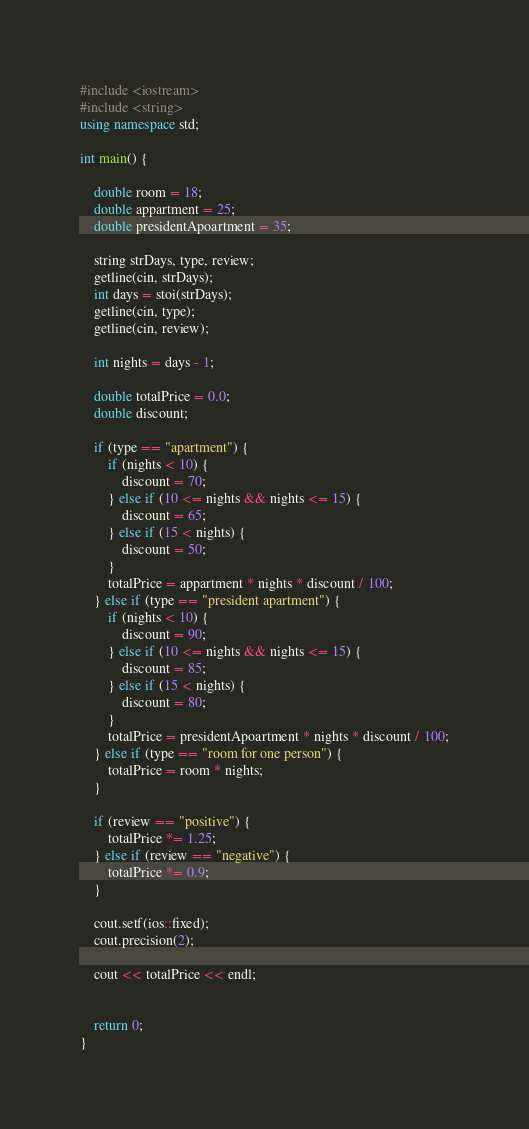<code> <loc_0><loc_0><loc_500><loc_500><_C++_>#include <iostream>
#include <string>
using namespace std;

int main() {

	double room = 18;
	double appartment = 25;
	double presidentApoartment = 35;

	string strDays, type, review;
	getline(cin, strDays);
	int days = stoi(strDays);
	getline(cin, type);
	getline(cin, review);

	int nights = days - 1;

	double totalPrice = 0.0;
	double discount;

	if (type == "apartment") {
		if (nights < 10) {
			discount = 70;
		} else if (10 <= nights && nights <= 15) {
			discount = 65;
		} else if (15 < nights) {
			discount = 50;
		}
		totalPrice = appartment * nights * discount / 100;
	} else if (type == "president apartment") {
		if (nights < 10) {
			discount = 90;
		} else if (10 <= nights && nights <= 15) {
			discount = 85;
		} else if (15 < nights) {
			discount = 80;
		}
		totalPrice = presidentApoartment * nights * discount / 100;
	} else if (type == "room for one person") {
		totalPrice = room * nights;
	}

	if (review == "positive") {
		totalPrice *= 1.25;
	} else if (review == "negative") {
		totalPrice *= 0.9;
	}

	cout.setf(ios::fixed);
	cout.precision(2);

	cout << totalPrice << endl;


	return 0;
}
</code> 